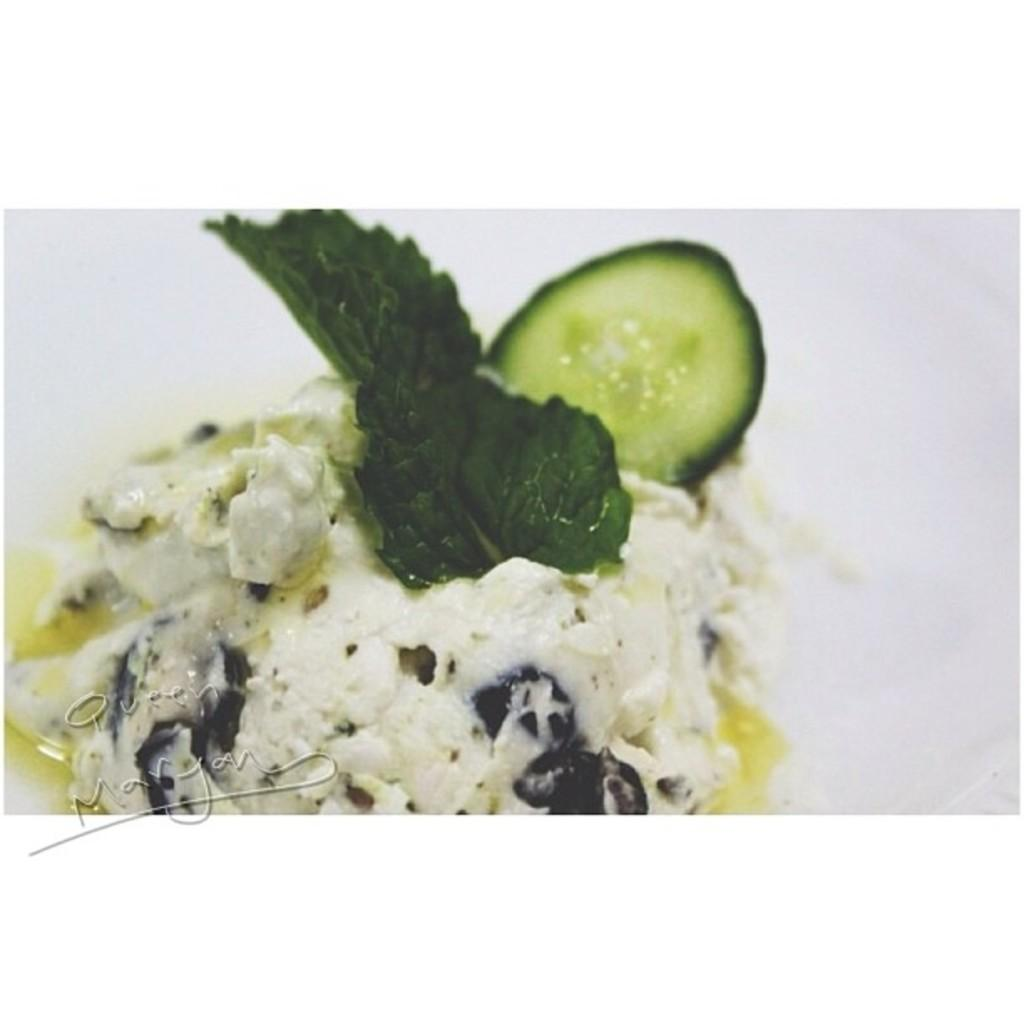What type of food can be seen in the image? There is dessert in the image. What is the color of the surface on which the dessert is placed? The dessert is on a white surface. Where is the dessert located in relation to the image? The dessert is in the foreground of the image. Can you see any deer or friends near the dessert in the image? No, there are no deer or friends visible in the image. Is the dessert located near an ocean in the image? No, there is no ocean present in the image. 